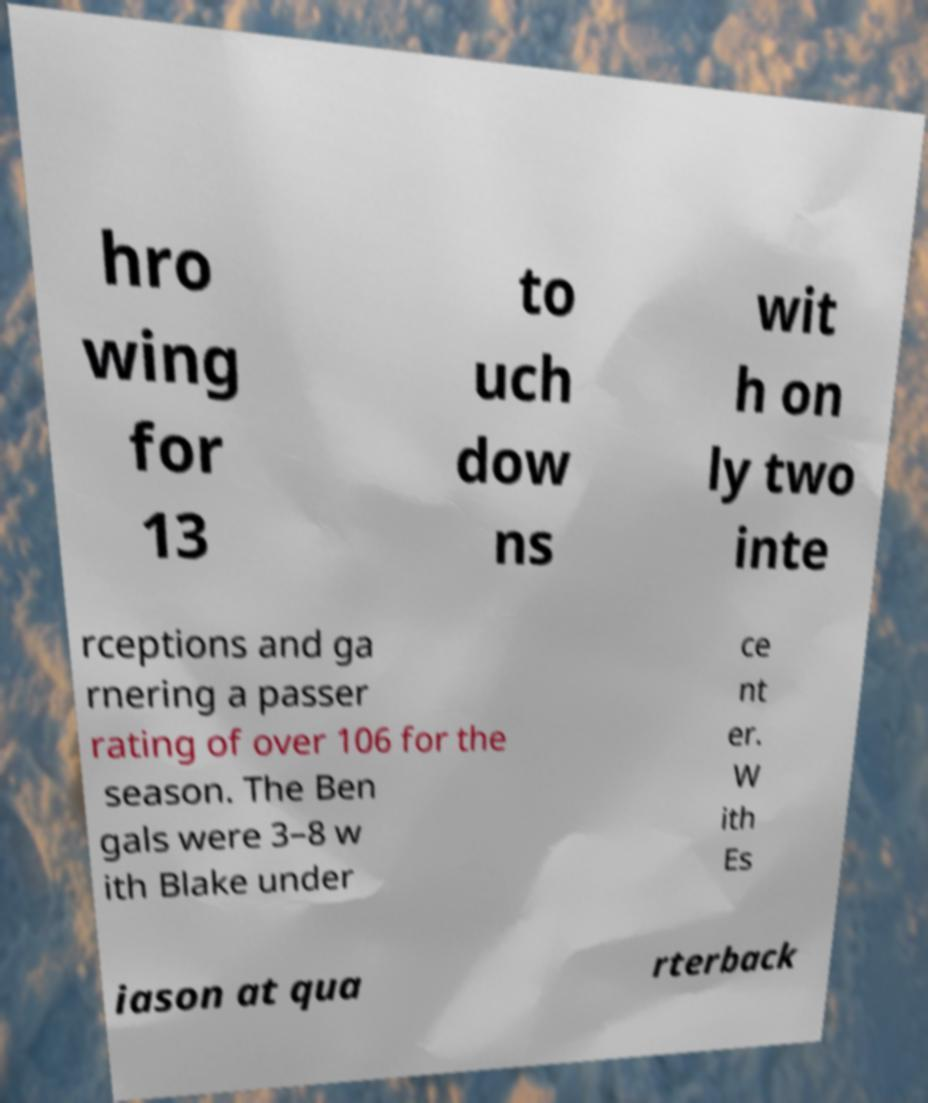There's text embedded in this image that I need extracted. Can you transcribe it verbatim? hro wing for 13 to uch dow ns wit h on ly two inte rceptions and ga rnering a passer rating of over 106 for the season. The Ben gals were 3–8 w ith Blake under ce nt er. W ith Es iason at qua rterback 